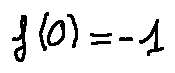<formula> <loc_0><loc_0><loc_500><loc_500>f ( 0 ) = - 1</formula> 